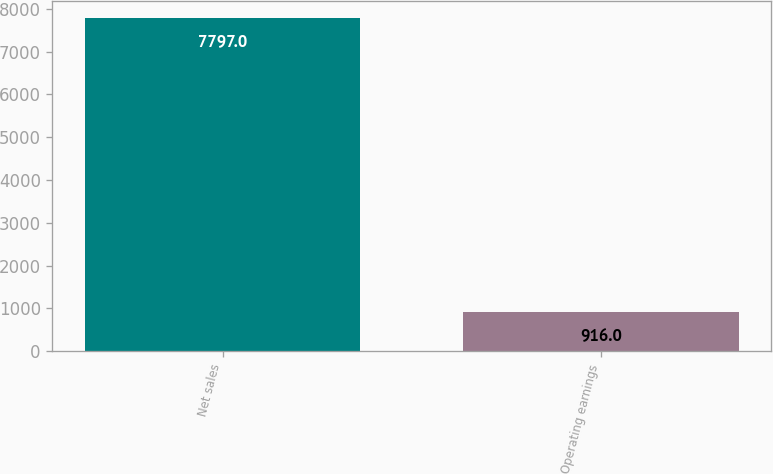Convert chart. <chart><loc_0><loc_0><loc_500><loc_500><bar_chart><fcel>Net sales<fcel>Operating earnings<nl><fcel>7797<fcel>916<nl></chart> 